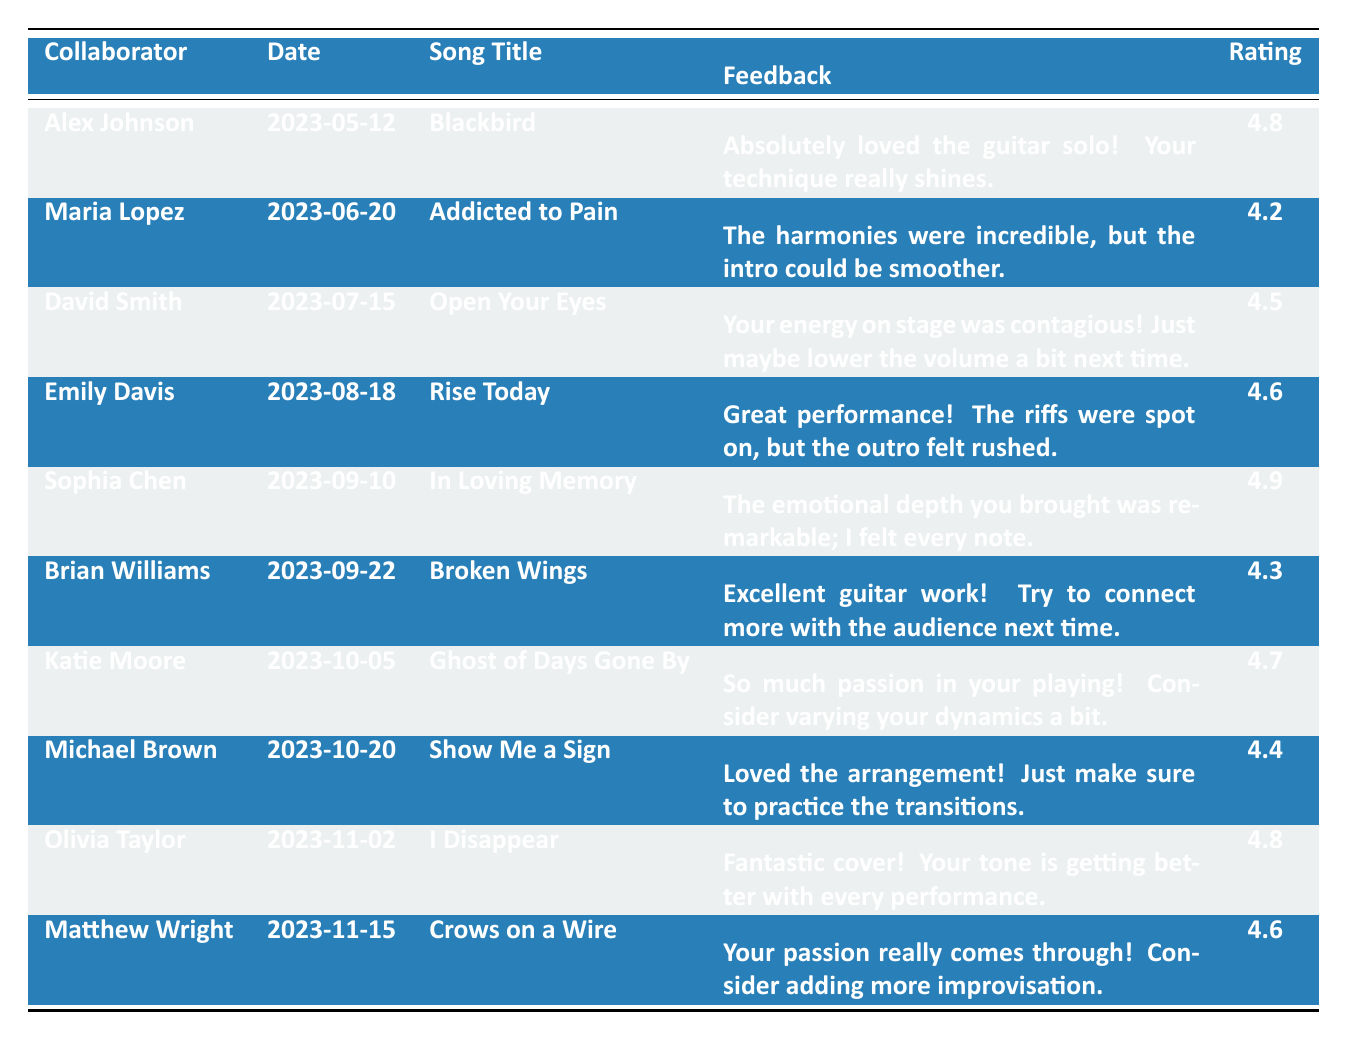What is the highest rating any collaborator gave for a performance? By scanning through the 'Rating' column in the table, the highest value observed is 4.9. It corresponds to the feedback given by Sophia Chen.
Answer: 4.9 Which song had the lowest rating, and who performed it? Looking at the 'Rating' column, the lowest rating is 4.2, which corresponds to the song "Addicted to Pain" performed by Maria Lopez.
Answer: Addicted to Pain by Maria Lopez What feedback did Brian Williams give regarding his performance? Referencing the 'Feedback' column associated with Brian Williams, he stated, "Excellent guitar work! Try to connect more with the audience next time."
Answer: Excellent guitar work! Try to connect more with the audience next time How many performances received a rating of 4.5 or higher? By counting the ratings that are 4.5 or higher (which are 4.8, 4.6, 4.9, 4.5, 4.7, 4.4, 4.8, and 4.6), there are a total of 8 performances.
Answer: 8 On which date did Emily Davis perform, and what song did she cover? The table indicates that Emily Davis performed on "2023-08-18" and the song covered was "Rise Today."
Answer: 2023-08-18, Rise Today Did any performance receive feedback suggesting a need for less volume? Yes, David Smith's performance of "Open Your Eyes" suggested lowering the volume a bit next time, indicating that feedback pointed to the volume being an area of improvement.
Answer: Yes What is the average rating of all performances? To find the average, sum the ratings (4.8 + 4.2 + 4.5 + 4.6 + 4.9 + 4.3 + 4.7 + 4.4 + 4.8 + 4.6) which equals 46.8. Then divide by 10, the number of performances, giving us 46.8 / 10 = 4.68.
Answer: 4.68 How many collaborators mentioned improving dynamics or improvisation? Katie Moore mentioned varying dynamics, and Matthew Wright suggested adding more improvisation. This makes a total of 2 collaborators mentioning improvements in these areas.
Answer: 2 Which song performed on 2023-11-15 received positive feedback about passion? Matthew Wright performed "Crows on a Wire" on this date and received feedback stating, "Your passion really comes through!"
Answer: Crows on a Wire Did any collaborator specifically praise the guitar work in their feedback? Yes, both Brian Williams and Alex Johnson praised the guitar work in their respective feedback.
Answer: Yes 